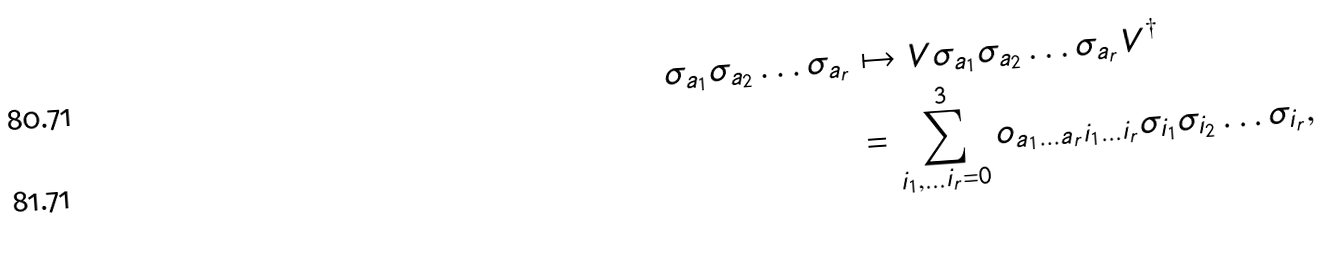<formula> <loc_0><loc_0><loc_500><loc_500>\sigma _ { a _ { 1 } } \sigma _ { a _ { 2 } } \dots \sigma _ { a _ { r } } & \mapsto V \sigma _ { a _ { 1 } } \sigma _ { a _ { 2 } } \dots \sigma _ { a _ { r } } V ^ { \dag } \\ & = \sum _ { i _ { 1 } , \dots i _ { r } = 0 } ^ { 3 } o _ { a _ { 1 } \dots a _ { r } i _ { 1 } \dots i _ { r } } \sigma _ { i _ { 1 } } \sigma _ { i _ { 2 } } \dots \sigma _ { i _ { r } } ,</formula> 